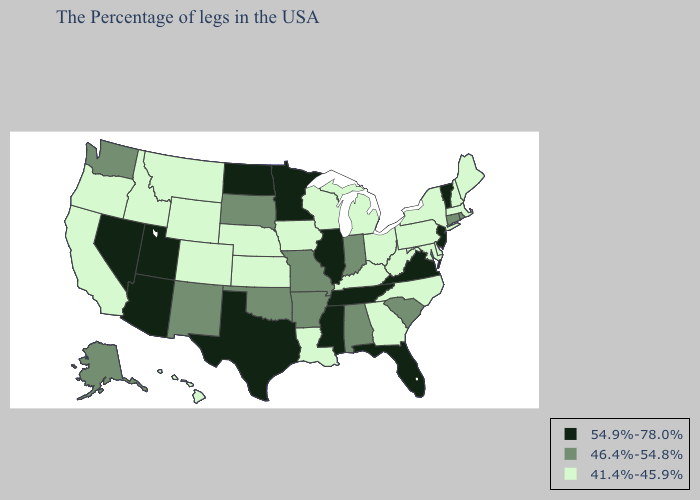Name the states that have a value in the range 46.4%-54.8%?
Short answer required. Rhode Island, Connecticut, South Carolina, Indiana, Alabama, Missouri, Arkansas, Oklahoma, South Dakota, New Mexico, Washington, Alaska. Which states have the lowest value in the South?
Concise answer only. Delaware, Maryland, North Carolina, West Virginia, Georgia, Kentucky, Louisiana. Which states have the highest value in the USA?
Short answer required. Vermont, New Jersey, Virginia, Florida, Tennessee, Illinois, Mississippi, Minnesota, Texas, North Dakota, Utah, Arizona, Nevada. Does Nebraska have a lower value than Iowa?
Give a very brief answer. No. What is the highest value in the USA?
Keep it brief. 54.9%-78.0%. What is the lowest value in the MidWest?
Quick response, please. 41.4%-45.9%. Name the states that have a value in the range 41.4%-45.9%?
Keep it brief. Maine, Massachusetts, New Hampshire, New York, Delaware, Maryland, Pennsylvania, North Carolina, West Virginia, Ohio, Georgia, Michigan, Kentucky, Wisconsin, Louisiana, Iowa, Kansas, Nebraska, Wyoming, Colorado, Montana, Idaho, California, Oregon, Hawaii. Name the states that have a value in the range 41.4%-45.9%?
Quick response, please. Maine, Massachusetts, New Hampshire, New York, Delaware, Maryland, Pennsylvania, North Carolina, West Virginia, Ohio, Georgia, Michigan, Kentucky, Wisconsin, Louisiana, Iowa, Kansas, Nebraska, Wyoming, Colorado, Montana, Idaho, California, Oregon, Hawaii. What is the value of Pennsylvania?
Write a very short answer. 41.4%-45.9%. What is the value of Alabama?
Answer briefly. 46.4%-54.8%. What is the lowest value in the South?
Answer briefly. 41.4%-45.9%. Among the states that border Pennsylvania , does New York have the lowest value?
Write a very short answer. Yes. Does Texas have the lowest value in the South?
Keep it brief. No. Does Ohio have a higher value than Washington?
Quick response, please. No. What is the value of Colorado?
Concise answer only. 41.4%-45.9%. 